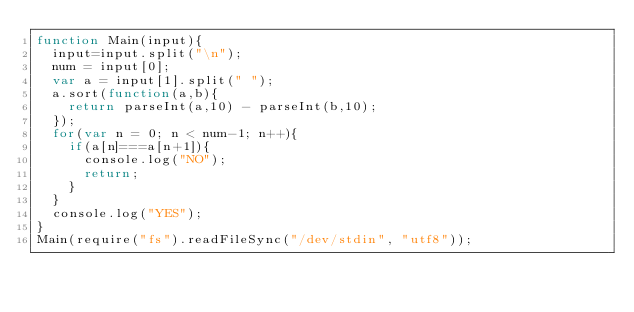Convert code to text. <code><loc_0><loc_0><loc_500><loc_500><_JavaScript_>function Main(input){
  input=input.split("\n");
  num = input[0];
  var a = input[1].split(" ");
  a.sort(function(a,b){
    return parseInt(a,10) - parseInt(b,10);
  });
  for(var n = 0; n < num-1; n++){
    if(a[n]===a[n+1]){
      console.log("NO");
      return;
    }
  }
  console.log("YES");
}
Main(require("fs").readFileSync("/dev/stdin", "utf8"));</code> 